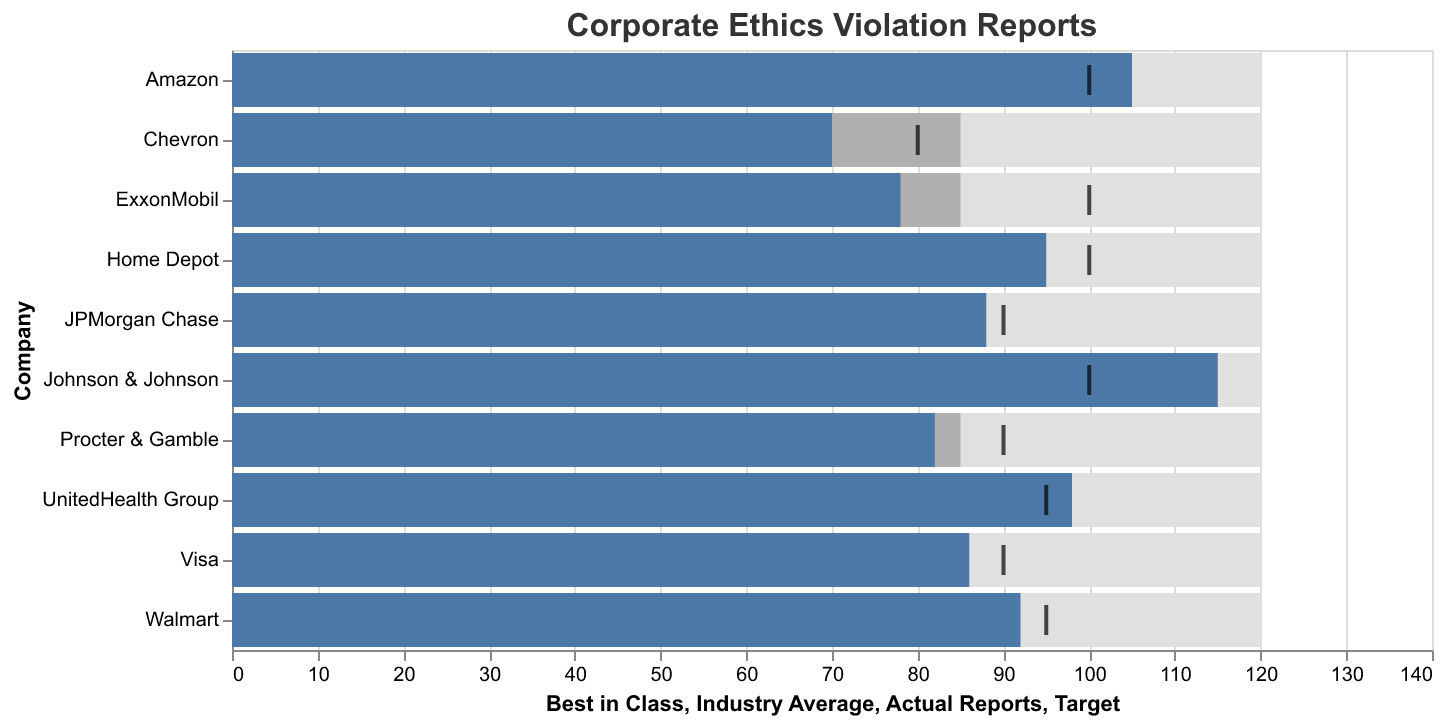What does the title of the figure indicate? The title "Corporate Ethics Violation Reports" suggests that the figure is displaying data related to reports of corporate ethics violations across different companies.
Answer: Corporate Ethics Violation Reports How many companies are represented in this figure? Counting the number of bars (or company labels) along the vertical axis will give the number of companies. There are 10 companies in the figure.
Answer: 10 What color represents the "Best in Class" values in the figure? The "Best in Class" values are represented by a light grey color in the figure.
Answer: Light grey Which company has the actual reports closest to its target value? By comparing the actual reports (blue bars) with the target values (black ticks), we can see that Walmart, with actual reports of 92 and target 95, is the closest to its target.
Answer: Walmart What is the highest number of actual reports among all companies? By looking for the longest blue bar, we can identify the highest number of actual reports. Johnson & Johnson has the highest actual reports at 115.
Answer: 115 Which companies reported fewer ethics violations than the industry average? By comparing the length of the blue bars (actual reports) to the grey bars (Industry Average at 85), Chevron and ExxonMobil both reported fewer violations than the industry average.
Answer: Chevron, ExxonMobil For Johnson & Johnson, how much do the actual reports exceed the industry average? Johnson & Johnson's actual reports are 115, and the industry average is 85. The difference is 115 - 85.
Answer: 30 How many companies exceeded their target for actual reports? By counting the number of blue bars exceeding the black ticks, we see that Johnson & Johnson and Amazon exceeded their targets.
Answer: 2 Which company has the longest blue bar, indicating the highest number of actual reports? The company with the longest blue bar is Johnson & Johnson.
Answer: Johnson & Johnson For Procter & Gamble, how far below the target are the actual reports? Procter & Gamble's actual reports are 82, and the target is 90. The difference is 90 - 82.
Answer: 8 